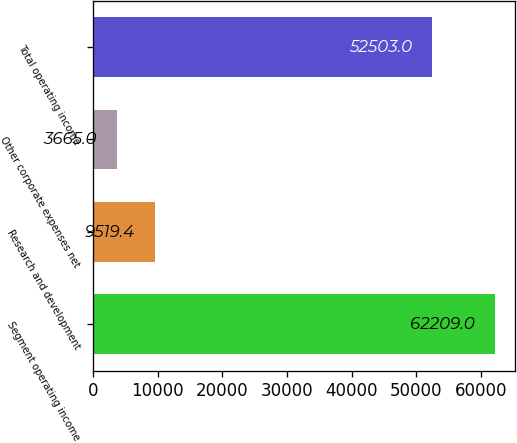Convert chart. <chart><loc_0><loc_0><loc_500><loc_500><bar_chart><fcel>Segment operating income<fcel>Research and development<fcel>Other corporate expenses net<fcel>Total operating income<nl><fcel>62209<fcel>9519.4<fcel>3665<fcel>52503<nl></chart> 